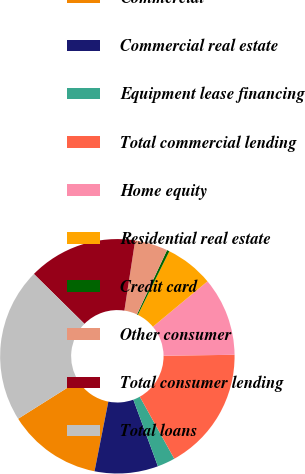Convert chart. <chart><loc_0><loc_0><loc_500><loc_500><pie_chart><fcel>Commercial<fcel>Commercial real estate<fcel>Equipment lease financing<fcel>Total commercial lending<fcel>Home equity<fcel>Residential real estate<fcel>Credit card<fcel>Other consumer<fcel>Total consumer lending<fcel>Total loans<nl><fcel>12.94%<fcel>8.74%<fcel>2.45%<fcel>17.13%<fcel>10.84%<fcel>6.64%<fcel>0.35%<fcel>4.54%<fcel>15.04%<fcel>21.33%<nl></chart> 